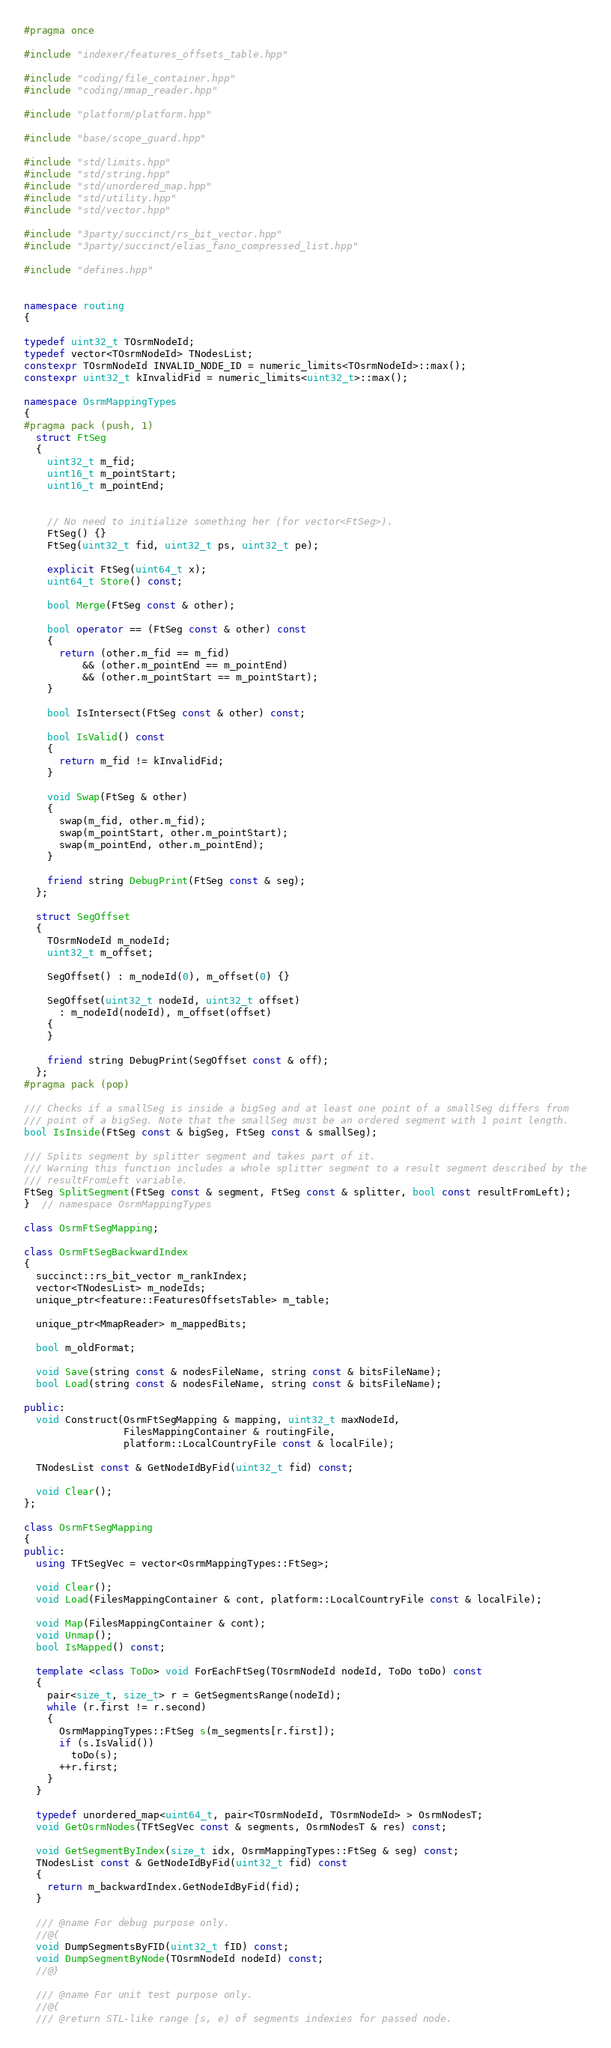Convert code to text. <code><loc_0><loc_0><loc_500><loc_500><_C++_>#pragma once

#include "indexer/features_offsets_table.hpp"

#include "coding/file_container.hpp"
#include "coding/mmap_reader.hpp"

#include "platform/platform.hpp"

#include "base/scope_guard.hpp"

#include "std/limits.hpp"
#include "std/string.hpp"
#include "std/unordered_map.hpp"
#include "std/utility.hpp"
#include "std/vector.hpp"

#include "3party/succinct/rs_bit_vector.hpp"
#include "3party/succinct/elias_fano_compressed_list.hpp"

#include "defines.hpp"


namespace routing
{

typedef uint32_t TOsrmNodeId;
typedef vector<TOsrmNodeId> TNodesList;
constexpr TOsrmNodeId INVALID_NODE_ID = numeric_limits<TOsrmNodeId>::max();
constexpr uint32_t kInvalidFid = numeric_limits<uint32_t>::max();

namespace OsrmMappingTypes
{
#pragma pack (push, 1)
  struct FtSeg
  {
    uint32_t m_fid;
    uint16_t m_pointStart;
    uint16_t m_pointEnd;


    // No need to initialize something her (for vector<FtSeg>).
    FtSeg() {}
    FtSeg(uint32_t fid, uint32_t ps, uint32_t pe);

    explicit FtSeg(uint64_t x);
    uint64_t Store() const;

    bool Merge(FtSeg const & other);

    bool operator == (FtSeg const & other) const
    {
      return (other.m_fid == m_fid)
          && (other.m_pointEnd == m_pointEnd)
          && (other.m_pointStart == m_pointStart);
    }

    bool IsIntersect(FtSeg const & other) const;

    bool IsValid() const
    {
      return m_fid != kInvalidFid;
    }

    void Swap(FtSeg & other)
    {
      swap(m_fid, other.m_fid);
      swap(m_pointStart, other.m_pointStart);
      swap(m_pointEnd, other.m_pointEnd);
    }

    friend string DebugPrint(FtSeg const & seg);
  };

  struct SegOffset
  {
    TOsrmNodeId m_nodeId;
    uint32_t m_offset;

    SegOffset() : m_nodeId(0), m_offset(0) {}

    SegOffset(uint32_t nodeId, uint32_t offset)
      : m_nodeId(nodeId), m_offset(offset)
    {
    }

    friend string DebugPrint(SegOffset const & off);
  };
#pragma pack (pop)

/// Checks if a smallSeg is inside a bigSeg and at least one point of a smallSeg differs from
/// point of a bigSeg. Note that the smallSeg must be an ordered segment with 1 point length.
bool IsInside(FtSeg const & bigSeg, FtSeg const & smallSeg);

/// Splits segment by splitter segment and takes part of it.
/// Warning this function includes a whole splitter segment to a result segment described by the
/// resultFromLeft variable.
FtSeg SplitSegment(FtSeg const & segment, FtSeg const & splitter, bool const resultFromLeft);
}  // namespace OsrmMappingTypes

class OsrmFtSegMapping;

class OsrmFtSegBackwardIndex
{
  succinct::rs_bit_vector m_rankIndex;
  vector<TNodesList> m_nodeIds;
  unique_ptr<feature::FeaturesOffsetsTable> m_table;

  unique_ptr<MmapReader> m_mappedBits;

  bool m_oldFormat;

  void Save(string const & nodesFileName, string const & bitsFileName);
  bool Load(string const & nodesFileName, string const & bitsFileName);

public:
  void Construct(OsrmFtSegMapping & mapping, uint32_t maxNodeId,
                 FilesMappingContainer & routingFile,
                 platform::LocalCountryFile const & localFile);

  TNodesList const & GetNodeIdByFid(uint32_t fid) const;

  void Clear();
};

class OsrmFtSegMapping
{
public:
  using TFtSegVec = vector<OsrmMappingTypes::FtSeg>;

  void Clear();
  void Load(FilesMappingContainer & cont, platform::LocalCountryFile const & localFile);

  void Map(FilesMappingContainer & cont);
  void Unmap();
  bool IsMapped() const;

  template <class ToDo> void ForEachFtSeg(TOsrmNodeId nodeId, ToDo toDo) const
  {
    pair<size_t, size_t> r = GetSegmentsRange(nodeId);
    while (r.first != r.second)
    {
      OsrmMappingTypes::FtSeg s(m_segments[r.first]);
      if (s.IsValid())
        toDo(s);
      ++r.first;
    }
  }

  typedef unordered_map<uint64_t, pair<TOsrmNodeId, TOsrmNodeId> > OsrmNodesT;
  void GetOsrmNodes(TFtSegVec const & segments, OsrmNodesT & res) const;

  void GetSegmentByIndex(size_t idx, OsrmMappingTypes::FtSeg & seg) const;
  TNodesList const & GetNodeIdByFid(uint32_t fid) const
  {
    return m_backwardIndex.GetNodeIdByFid(fid);
  }

  /// @name For debug purpose only.
  //@{
  void DumpSegmentsByFID(uint32_t fID) const;
  void DumpSegmentByNode(TOsrmNodeId nodeId) const;
  //@}

  /// @name For unit test purpose only.
  //@{
  /// @return STL-like range [s, e) of segments indexies for passed node.</code> 